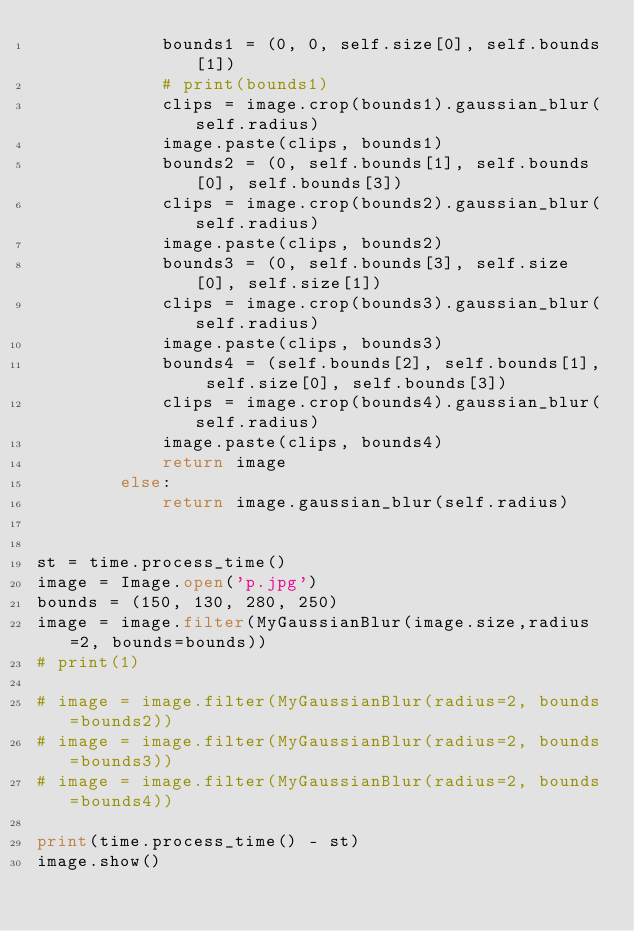<code> <loc_0><loc_0><loc_500><loc_500><_Python_>            bounds1 = (0, 0, self.size[0], self.bounds[1])
            # print(bounds1)
            clips = image.crop(bounds1).gaussian_blur(self.radius)
            image.paste(clips, bounds1)
            bounds2 = (0, self.bounds[1], self.bounds[0], self.bounds[3])
            clips = image.crop(bounds2).gaussian_blur(self.radius)
            image.paste(clips, bounds2)
            bounds3 = (0, self.bounds[3], self.size[0], self.size[1])
            clips = image.crop(bounds3).gaussian_blur(self.radius)
            image.paste(clips, bounds3)
            bounds4 = (self.bounds[2], self.bounds[1], self.size[0], self.bounds[3])
            clips = image.crop(bounds4).gaussian_blur(self.radius)
            image.paste(clips, bounds4)
            return image
        else:
            return image.gaussian_blur(self.radius)


st = time.process_time()
image = Image.open('p.jpg')
bounds = (150, 130, 280, 250)
image = image.filter(MyGaussianBlur(image.size,radius=2, bounds=bounds))
# print(1)

# image = image.filter(MyGaussianBlur(radius=2, bounds=bounds2))
# image = image.filter(MyGaussianBlur(radius=2, bounds=bounds3))
# image = image.filter(MyGaussianBlur(radius=2, bounds=bounds4))

print(time.process_time() - st)
image.show()
</code> 